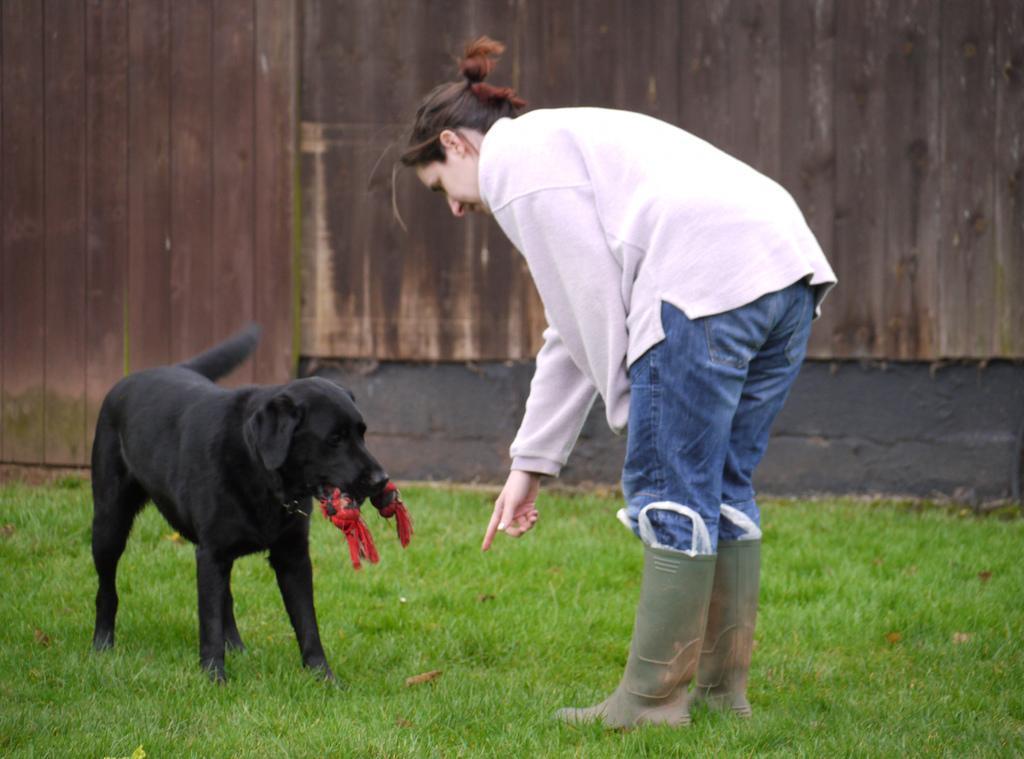Describe this image in one or two sentences. In this picture there is a women who is wearing a pink color jacket and blue color jeans. And she is bend over to the dog. A black dog who is holding a red object in his mouth. On the bottom we can see a grass. On the background there is a wooden wall. 